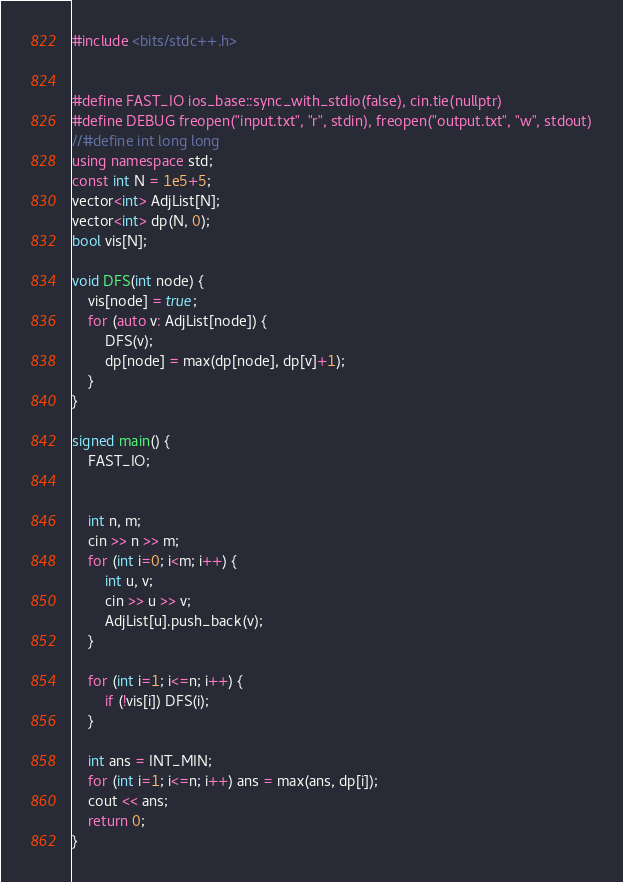Convert code to text. <code><loc_0><loc_0><loc_500><loc_500><_C++_>#include <bits/stdc++.h>


#define FAST_IO ios_base::sync_with_stdio(false), cin.tie(nullptr)
#define DEBUG freopen("input.txt", "r", stdin), freopen("output.txt", "w", stdout)
//#define int long long
using namespace std;
const int N = 1e5+5;
vector<int> AdjList[N];
vector<int> dp(N, 0);
bool vis[N];

void DFS(int node) {
	vis[node] = true;
	for (auto v: AdjList[node]) {
		DFS(v);
		dp[node] = max(dp[node], dp[v]+1);
	}
}

signed main() {
	FAST_IO;


	int n, m;
	cin >> n >> m;
	for (int i=0; i<m; i++) {
		int u, v;
		cin >> u >> v;
		AdjList[u].push_back(v);
	}

	for (int i=1; i<=n; i++) {
		if (!vis[i]) DFS(i);
	}

	int ans = INT_MIN;
	for (int i=1; i<=n; i++) ans = max(ans, dp[i]);
	cout << ans;
	return 0;
}</code> 